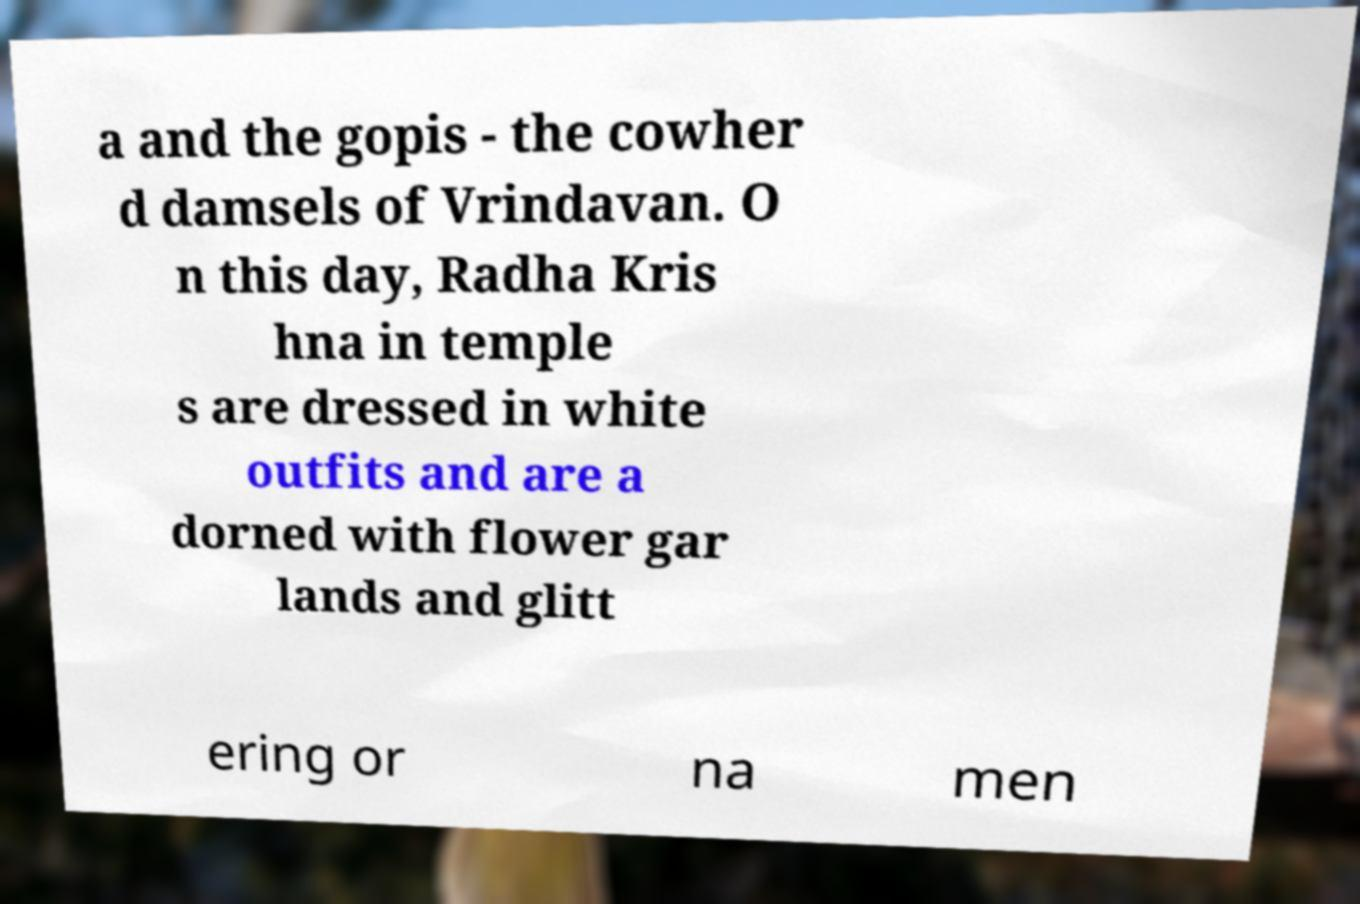There's text embedded in this image that I need extracted. Can you transcribe it verbatim? a and the gopis - the cowher d damsels of Vrindavan. O n this day, Radha Kris hna in temple s are dressed in white outfits and are a dorned with flower gar lands and glitt ering or na men 